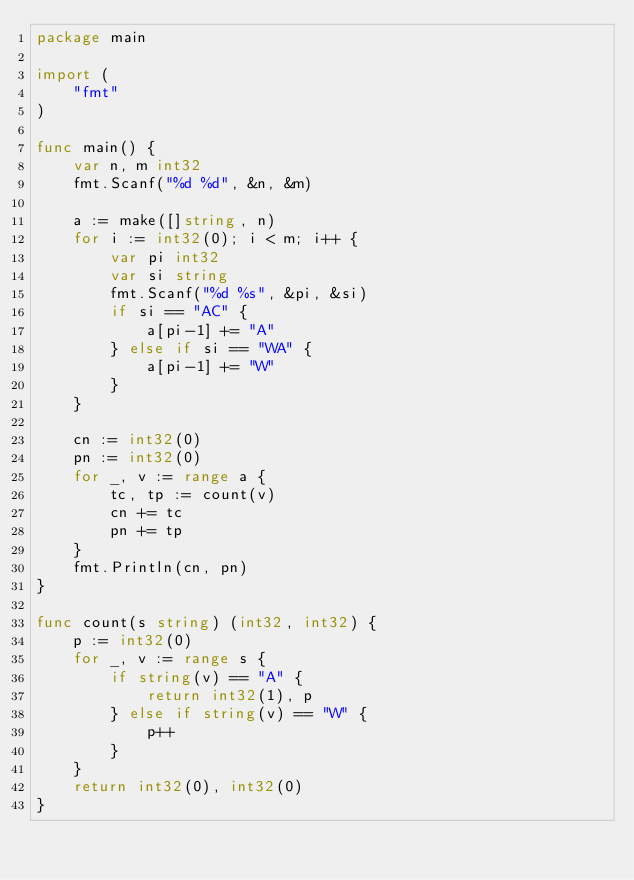<code> <loc_0><loc_0><loc_500><loc_500><_Go_>package main

import (
	"fmt"
)

func main() {
	var n, m int32
	fmt.Scanf("%d %d", &n, &m)

	a := make([]string, n)
	for i := int32(0); i < m; i++ {
		var pi int32
		var si string
		fmt.Scanf("%d %s", &pi, &si)
		if si == "AC" {
			a[pi-1] += "A"
		} else if si == "WA" {
			a[pi-1] += "W"
		}
	}

	cn := int32(0)
	pn := int32(0)
	for _, v := range a {
		tc, tp := count(v)
		cn += tc
		pn += tp
	}
	fmt.Println(cn, pn)
}

func count(s string) (int32, int32) {
	p := int32(0)
	for _, v := range s {
		if string(v) == "A" {
			return int32(1), p
		} else if string(v) == "W" {
			p++
		}
	}
	return int32(0), int32(0)
}
</code> 